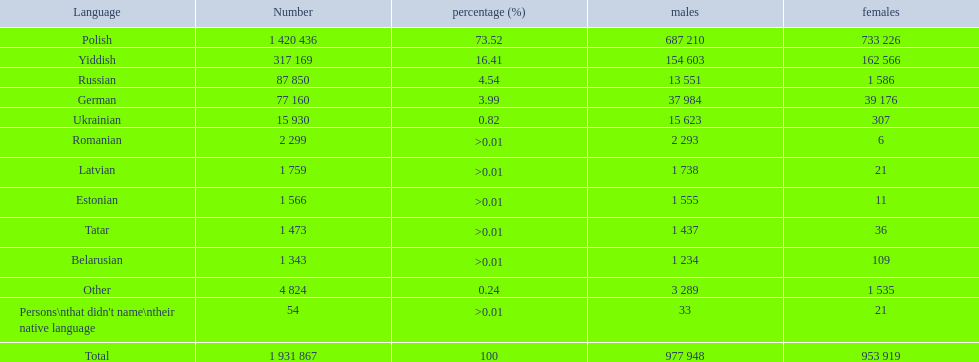What are all the linguistic systems? Polish, Yiddish, Russian, German, Ukrainian, Romanian, Latvian, Estonian, Tatar, Belarusian, Other, Persons\nthat didn't name\ntheir native language. Of those systems, which five had below 50 females communicating in it? 6, 21, 11, 36, 21. Of those five systems, which is the lowest? Romanian. 